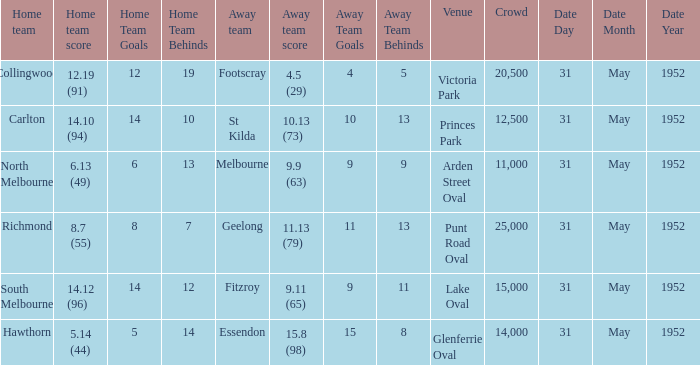When was the game when Footscray was the away team? 31 May 1952. 